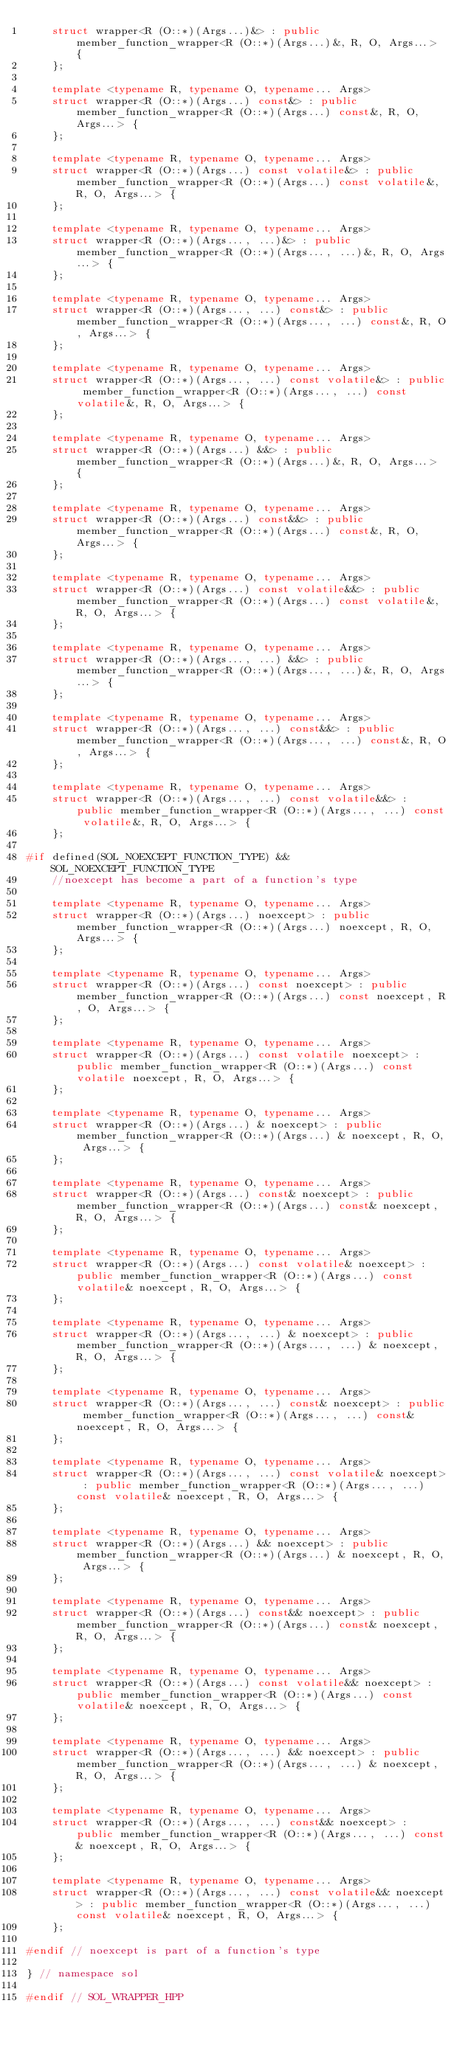Convert code to text. <code><loc_0><loc_0><loc_500><loc_500><_C++_>	struct wrapper<R (O::*)(Args...)&> : public member_function_wrapper<R (O::*)(Args...)&, R, O, Args...> {
	};

	template <typename R, typename O, typename... Args>
	struct wrapper<R (O::*)(Args...) const&> : public member_function_wrapper<R (O::*)(Args...) const&, R, O, Args...> {
	};

	template <typename R, typename O, typename... Args>
	struct wrapper<R (O::*)(Args...) const volatile&> : public member_function_wrapper<R (O::*)(Args...) const volatile&, R, O, Args...> {
	};

	template <typename R, typename O, typename... Args>
	struct wrapper<R (O::*)(Args..., ...)&> : public member_function_wrapper<R (O::*)(Args..., ...)&, R, O, Args...> {
	};

	template <typename R, typename O, typename... Args>
	struct wrapper<R (O::*)(Args..., ...) const&> : public member_function_wrapper<R (O::*)(Args..., ...) const&, R, O, Args...> {
	};

	template <typename R, typename O, typename... Args>
	struct wrapper<R (O::*)(Args..., ...) const volatile&> : public member_function_wrapper<R (O::*)(Args..., ...) const volatile&, R, O, Args...> {
	};

	template <typename R, typename O, typename... Args>
	struct wrapper<R (O::*)(Args...) &&> : public member_function_wrapper<R (O::*)(Args...)&, R, O, Args...> {
	};

	template <typename R, typename O, typename... Args>
	struct wrapper<R (O::*)(Args...) const&&> : public member_function_wrapper<R (O::*)(Args...) const&, R, O, Args...> {
	};

	template <typename R, typename O, typename... Args>
	struct wrapper<R (O::*)(Args...) const volatile&&> : public member_function_wrapper<R (O::*)(Args...) const volatile&, R, O, Args...> {
	};

	template <typename R, typename O, typename... Args>
	struct wrapper<R (O::*)(Args..., ...) &&> : public member_function_wrapper<R (O::*)(Args..., ...)&, R, O, Args...> {
	};

	template <typename R, typename O, typename... Args>
	struct wrapper<R (O::*)(Args..., ...) const&&> : public member_function_wrapper<R (O::*)(Args..., ...) const&, R, O, Args...> {
	};

	template <typename R, typename O, typename... Args>
	struct wrapper<R (O::*)(Args..., ...) const volatile&&> : public member_function_wrapper<R (O::*)(Args..., ...) const volatile&, R, O, Args...> {
	};

#if defined(SOL_NOEXCEPT_FUNCTION_TYPE) && SOL_NOEXCEPT_FUNCTION_TYPE
	//noexcept has become a part of a function's type

	template <typename R, typename O, typename... Args>
	struct wrapper<R (O::*)(Args...) noexcept> : public member_function_wrapper<R (O::*)(Args...) noexcept, R, O, Args...> {
	};

	template <typename R, typename O, typename... Args>
	struct wrapper<R (O::*)(Args...) const noexcept> : public member_function_wrapper<R (O::*)(Args...) const noexcept, R, O, Args...> {
	};

	template <typename R, typename O, typename... Args>
	struct wrapper<R (O::*)(Args...) const volatile noexcept> : public member_function_wrapper<R (O::*)(Args...) const volatile noexcept, R, O, Args...> {
	};

	template <typename R, typename O, typename... Args>
	struct wrapper<R (O::*)(Args...) & noexcept> : public member_function_wrapper<R (O::*)(Args...) & noexcept, R, O, Args...> {
	};

	template <typename R, typename O, typename... Args>
	struct wrapper<R (O::*)(Args...) const& noexcept> : public member_function_wrapper<R (O::*)(Args...) const& noexcept, R, O, Args...> {
	};

	template <typename R, typename O, typename... Args>
	struct wrapper<R (O::*)(Args...) const volatile& noexcept> : public member_function_wrapper<R (O::*)(Args...) const volatile& noexcept, R, O, Args...> {
	};

	template <typename R, typename O, typename... Args>
	struct wrapper<R (O::*)(Args..., ...) & noexcept> : public member_function_wrapper<R (O::*)(Args..., ...) & noexcept, R, O, Args...> {
	};

	template <typename R, typename O, typename... Args>
	struct wrapper<R (O::*)(Args..., ...) const& noexcept> : public member_function_wrapper<R (O::*)(Args..., ...) const& noexcept, R, O, Args...> {
	};

	template <typename R, typename O, typename... Args>
	struct wrapper<R (O::*)(Args..., ...) const volatile& noexcept> : public member_function_wrapper<R (O::*)(Args..., ...) const volatile& noexcept, R, O, Args...> {
	};

	template <typename R, typename O, typename... Args>
	struct wrapper<R (O::*)(Args...) && noexcept> : public member_function_wrapper<R (O::*)(Args...) & noexcept, R, O, Args...> {
	};

	template <typename R, typename O, typename... Args>
	struct wrapper<R (O::*)(Args...) const&& noexcept> : public member_function_wrapper<R (O::*)(Args...) const& noexcept, R, O, Args...> {
	};

	template <typename R, typename O, typename... Args>
	struct wrapper<R (O::*)(Args...) const volatile&& noexcept> : public member_function_wrapper<R (O::*)(Args...) const volatile& noexcept, R, O, Args...> {
	};

	template <typename R, typename O, typename... Args>
	struct wrapper<R (O::*)(Args..., ...) && noexcept> : public member_function_wrapper<R (O::*)(Args..., ...) & noexcept, R, O, Args...> {
	};

	template <typename R, typename O, typename... Args>
	struct wrapper<R (O::*)(Args..., ...) const&& noexcept> : public member_function_wrapper<R (O::*)(Args..., ...) const& noexcept, R, O, Args...> {
	};

	template <typename R, typename O, typename... Args>
	struct wrapper<R (O::*)(Args..., ...) const volatile&& noexcept> : public member_function_wrapper<R (O::*)(Args..., ...) const volatile& noexcept, R, O, Args...> {
	};

#endif // noexcept is part of a function's type

} // namespace sol

#endif // SOL_WRAPPER_HPP
</code> 